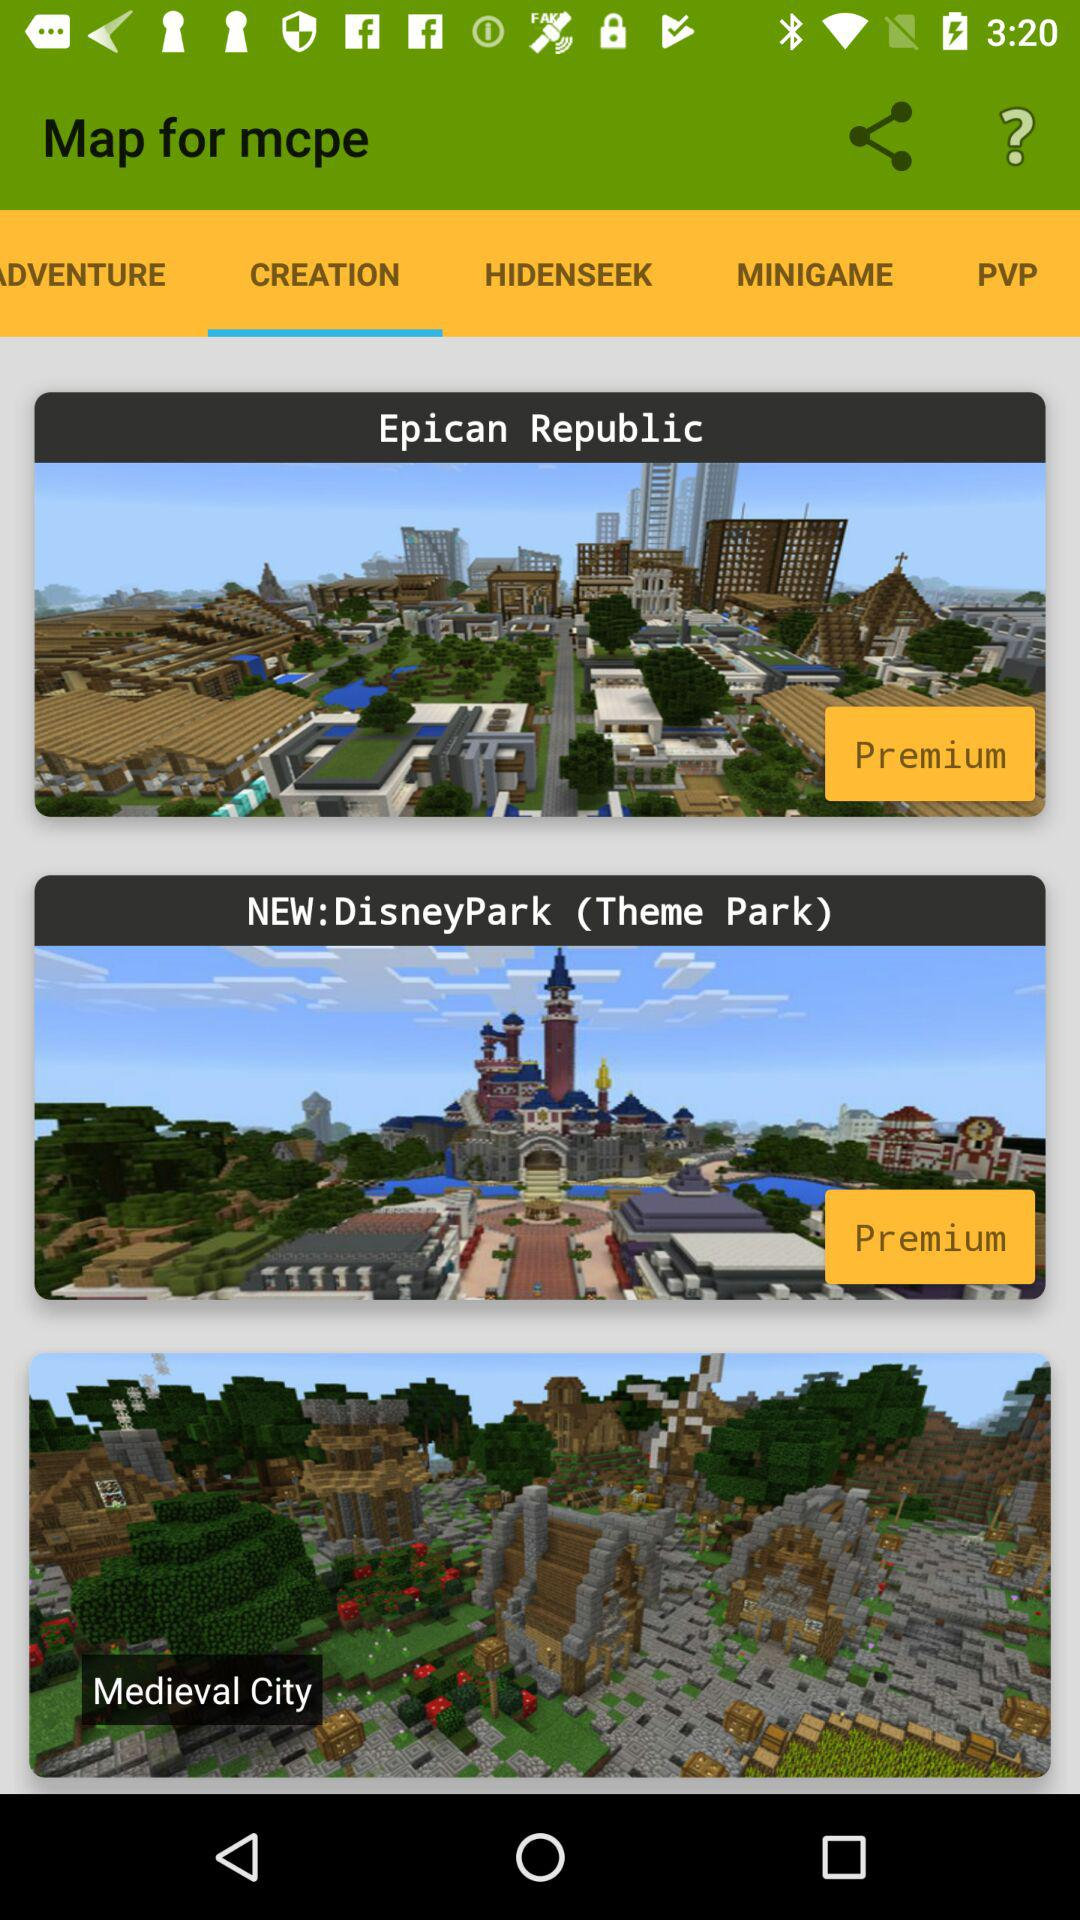Which tab am I on? You are on the "CREATION" tab. 